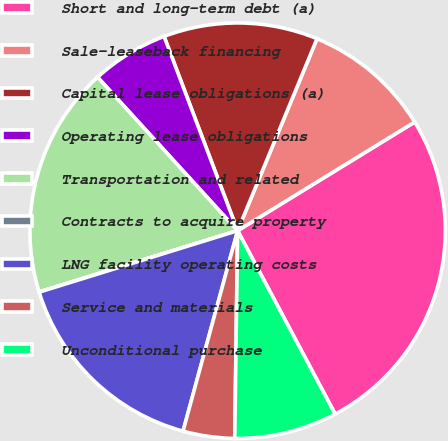Convert chart. <chart><loc_0><loc_0><loc_500><loc_500><pie_chart><fcel>Short and long-term debt (a)<fcel>Sale-leaseback financing<fcel>Capital lease obligations (a)<fcel>Operating lease obligations<fcel>Transportation and related<fcel>Contracts to acquire property<fcel>LNG facility operating costs<fcel>Service and materials<fcel>Unconditional purchase<nl><fcel>25.98%<fcel>10.0%<fcel>12.0%<fcel>6.01%<fcel>17.99%<fcel>0.02%<fcel>15.99%<fcel>4.01%<fcel>8.0%<nl></chart> 